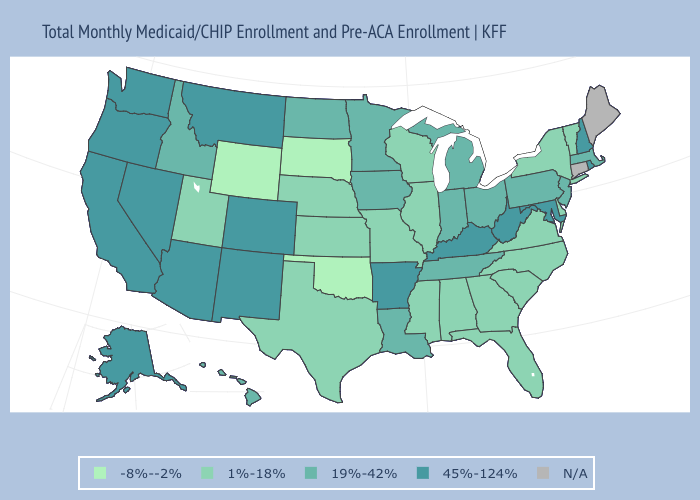Does the first symbol in the legend represent the smallest category?
Answer briefly. Yes. Among the states that border South Dakota , which have the lowest value?
Quick response, please. Wyoming. What is the highest value in the South ?
Concise answer only. 45%-124%. What is the highest value in the USA?
Be succinct. 45%-124%. What is the highest value in states that border Vermont?
Concise answer only. 45%-124%. What is the lowest value in the West?
Keep it brief. -8%--2%. Does Vermont have the lowest value in the Northeast?
Write a very short answer. Yes. What is the value of Virginia?
Short answer required. 1%-18%. Name the states that have a value in the range N/A?
Write a very short answer. Connecticut, Maine. Does the map have missing data?
Be succinct. Yes. Which states hav the highest value in the Northeast?
Answer briefly. New Hampshire, Rhode Island. Does North Dakota have the lowest value in the MidWest?
Short answer required. No. What is the value of Massachusetts?
Be succinct. 19%-42%. Among the states that border Oregon , does California have the highest value?
Give a very brief answer. Yes. 